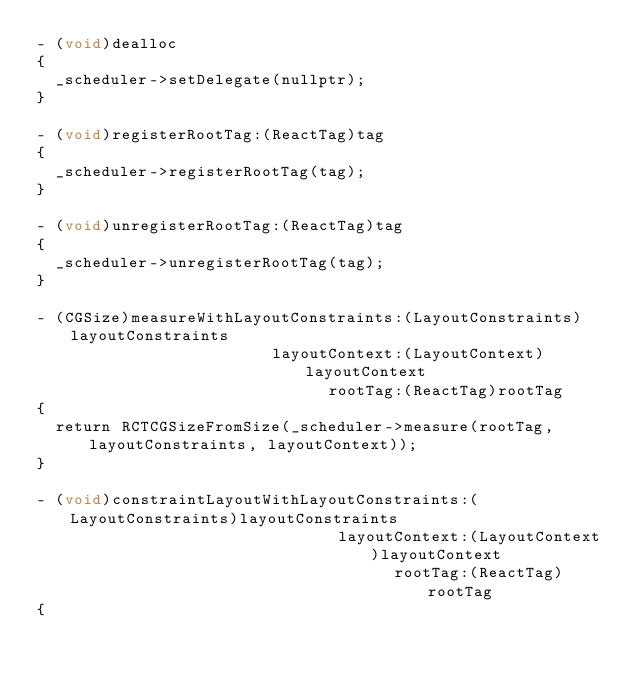<code> <loc_0><loc_0><loc_500><loc_500><_ObjectiveC_>- (void)dealloc
{
  _scheduler->setDelegate(nullptr);
}

- (void)registerRootTag:(ReactTag)tag
{
  _scheduler->registerRootTag(tag);
}

- (void)unregisterRootTag:(ReactTag)tag
{
  _scheduler->unregisterRootTag(tag);
}

- (CGSize)measureWithLayoutConstraints:(LayoutConstraints)layoutConstraints
                         layoutContext:(LayoutContext)layoutContext
                               rootTag:(ReactTag)rootTag
{
  return RCTCGSizeFromSize(_scheduler->measure(rootTag, layoutConstraints, layoutContext));
}

- (void)constraintLayoutWithLayoutConstraints:(LayoutConstraints)layoutConstraints
                                layoutContext:(LayoutContext)layoutContext
                                      rootTag:(ReactTag)rootTag
{</code> 